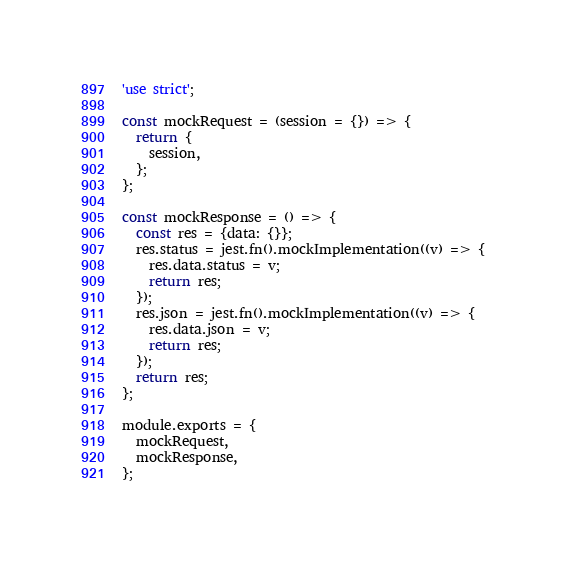<code> <loc_0><loc_0><loc_500><loc_500><_JavaScript_>'use strict';

const mockRequest = (session = {}) => {
  return {
    session,
  };
};

const mockResponse = () => {
  const res = {data: {}};
  res.status = jest.fn().mockImplementation((v) => {
    res.data.status = v;
    return res;
  });
  res.json = jest.fn().mockImplementation((v) => {
    res.data.json = v;
    return res; 
  });
  return res;
};

module.exports = {
  mockRequest,
  mockResponse,
};
</code> 